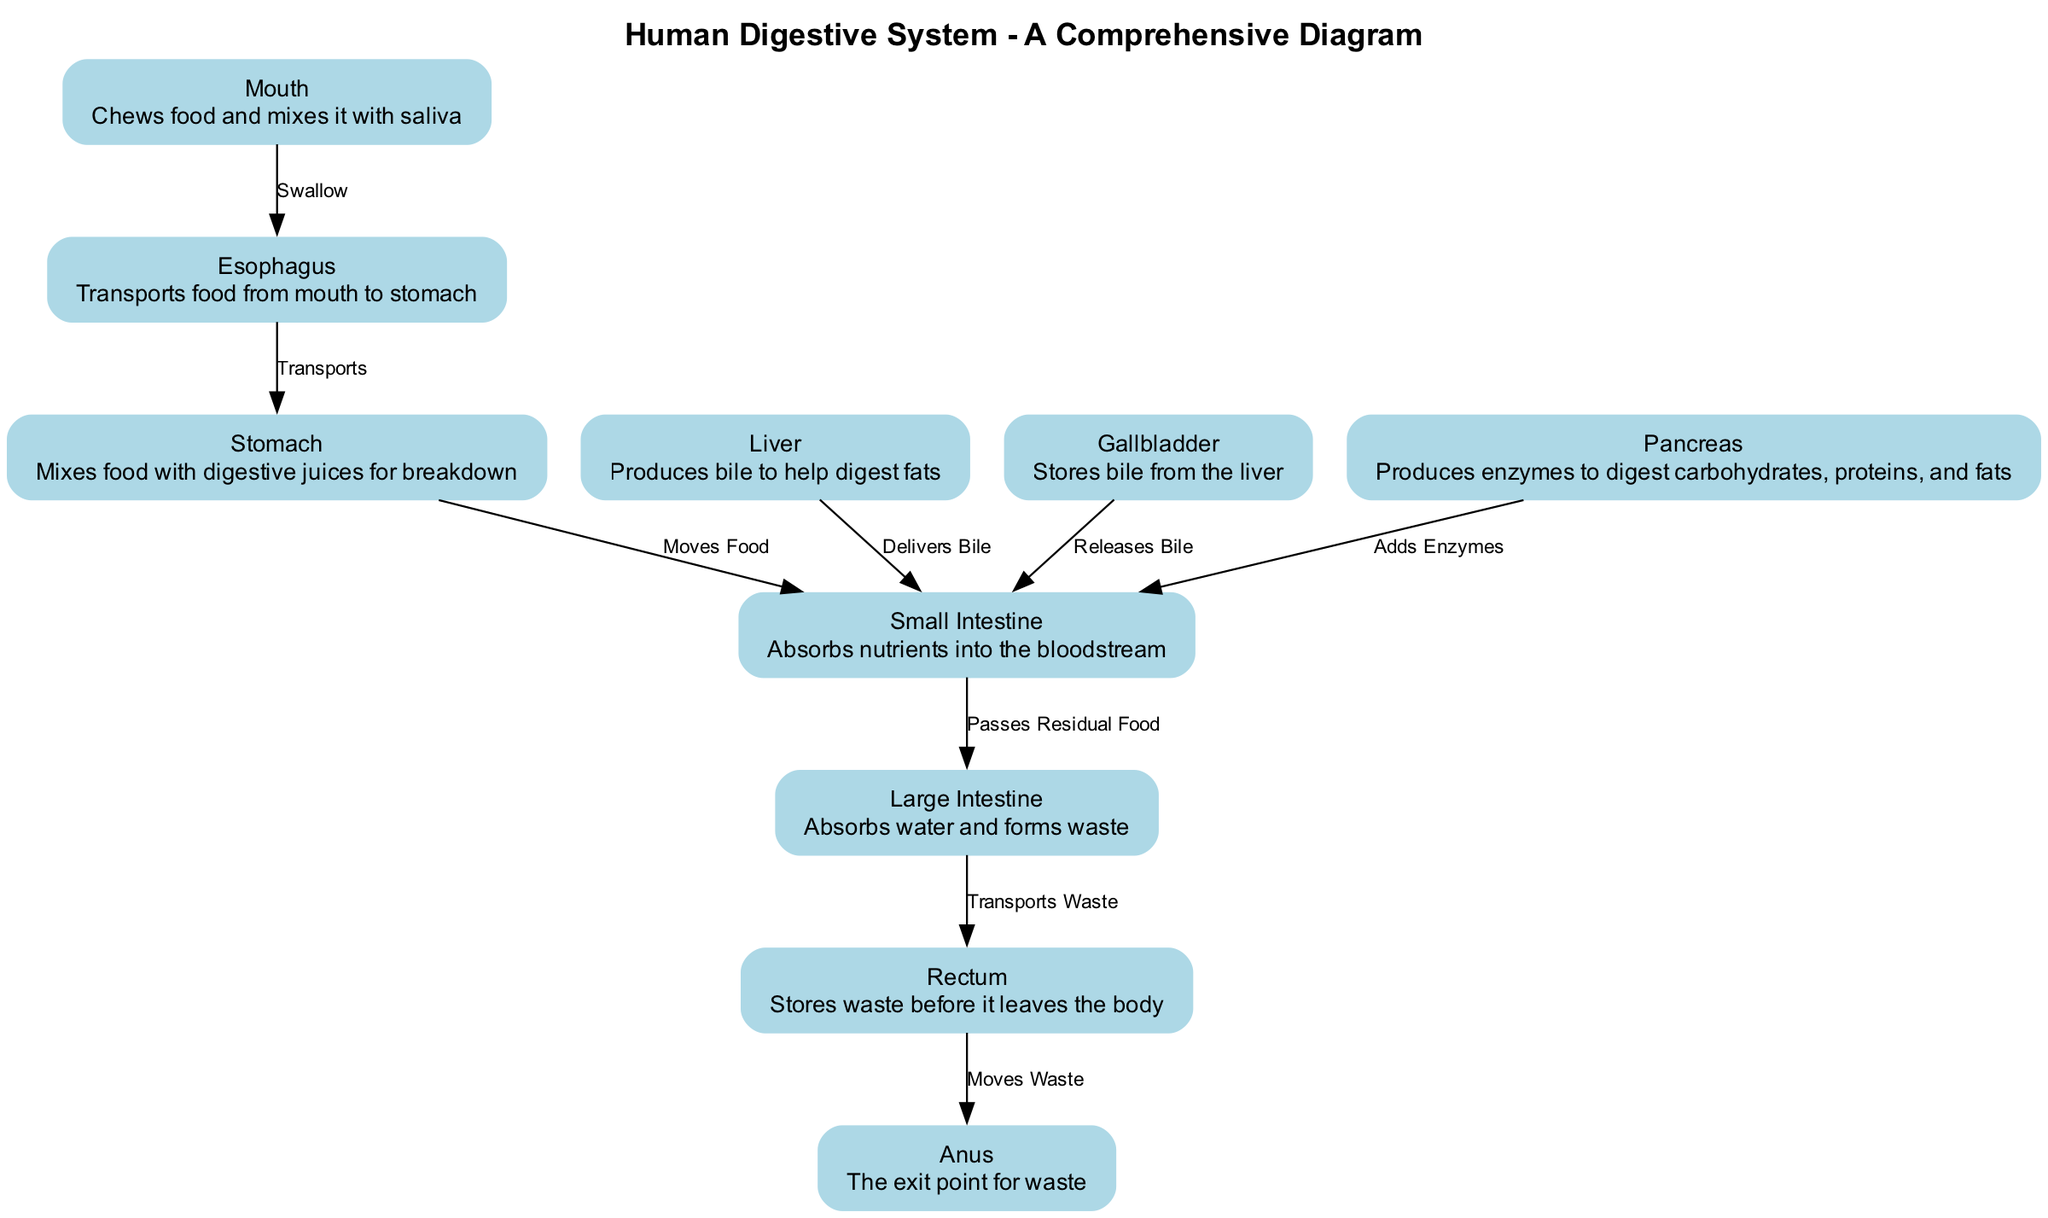What is the first organ in the digestive system? The diagram starts with the "Mouth," which is where digestion begins as food is chewed and mixed with saliva.
Answer: Mouth What is the function of the stomach? The "Stomach" mixes food with digestive juices to break it down into a semi-liquid form, preparing it for further digestion.
Answer: Mixes food with digestive juices for breakdown How many organs are involved in the human digestive system according to the diagram? The diagram shows a total of 10 organs, which are the mouth, esophagus, stomach, liver, gallbladder, pancreas, small intestine, large intestine, rectum, and anus.
Answer: 10 What does the liver produce to help with digestion? The diagram states that the "Liver" produces bile, which assists in the digestion of fats.
Answer: Bile Which organ absorbs nutrients into the bloodstream? The diagram specifies that the "Small Intestine" is responsible for absorbing nutrients after the food is broken down.
Answer: Small Intestine What happens after food leaves the stomach? According to the diagram, once food leaves the "Stomach," it moves to the "Small Intestine" where further digestion and nutrient absorption occurs.
Answer: Moves Food What is the role of the pancreas in digestion? The diagram indicates that the "Pancreas" produces enzymes that help digest carbohydrates, proteins, and fats, which are then added to the small intestine.
Answer: Produces enzymes to digest carbohydrates, proteins, and fats Through which organ does waste exit the body? The diagram shows that waste is stored in the "Rectum" before it is expelled through the "Anus," making the anus the exit point for waste.
Answer: Anus What connects the esophagus to the stomach? The diagram indicates that the relationship is depicted with an edge labeled "Transports," showing that the esophagus connects to the stomach by transporting food.
Answer: Transports How does bile reach the small intestine? The diagram illustrates that bile is delivered from the liver and released from the gallbladder to the small intestine, indicating both organs contribute to this process.
Answer: Delivers Bile, Releases Bile 